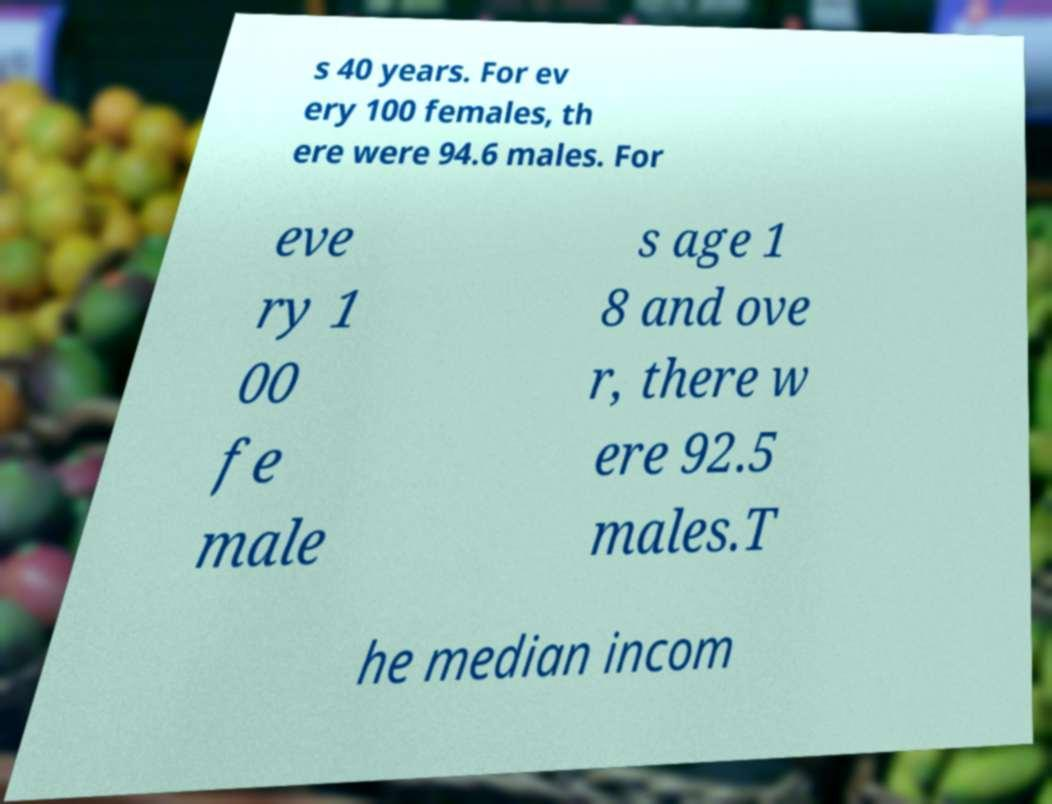What messages or text are displayed in this image? I need them in a readable, typed format. s 40 years. For ev ery 100 females, th ere were 94.6 males. For eve ry 1 00 fe male s age 1 8 and ove r, there w ere 92.5 males.T he median incom 